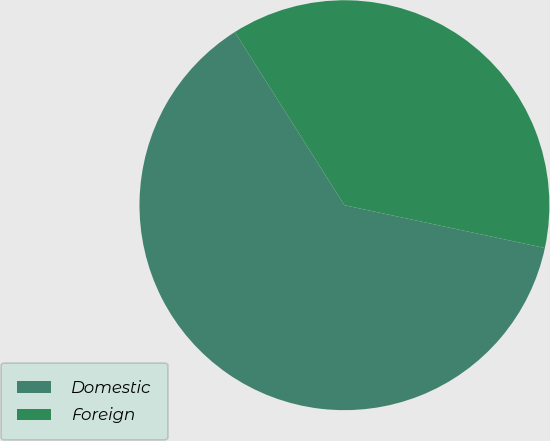Convert chart to OTSL. <chart><loc_0><loc_0><loc_500><loc_500><pie_chart><fcel>Domestic<fcel>Foreign<nl><fcel>62.67%<fcel>37.33%<nl></chart> 